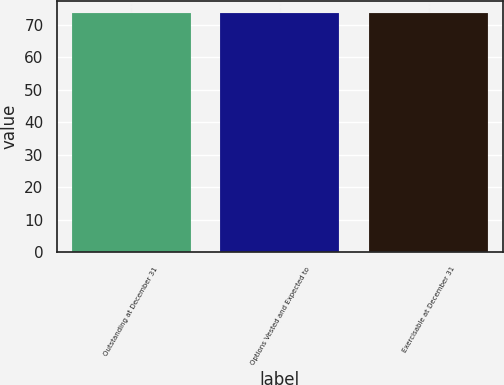<chart> <loc_0><loc_0><loc_500><loc_500><bar_chart><fcel>Outstanding at December 31<fcel>Options Vested and Expected to<fcel>Exercisable at December 31<nl><fcel>73.73<fcel>73.75<fcel>73.52<nl></chart> 